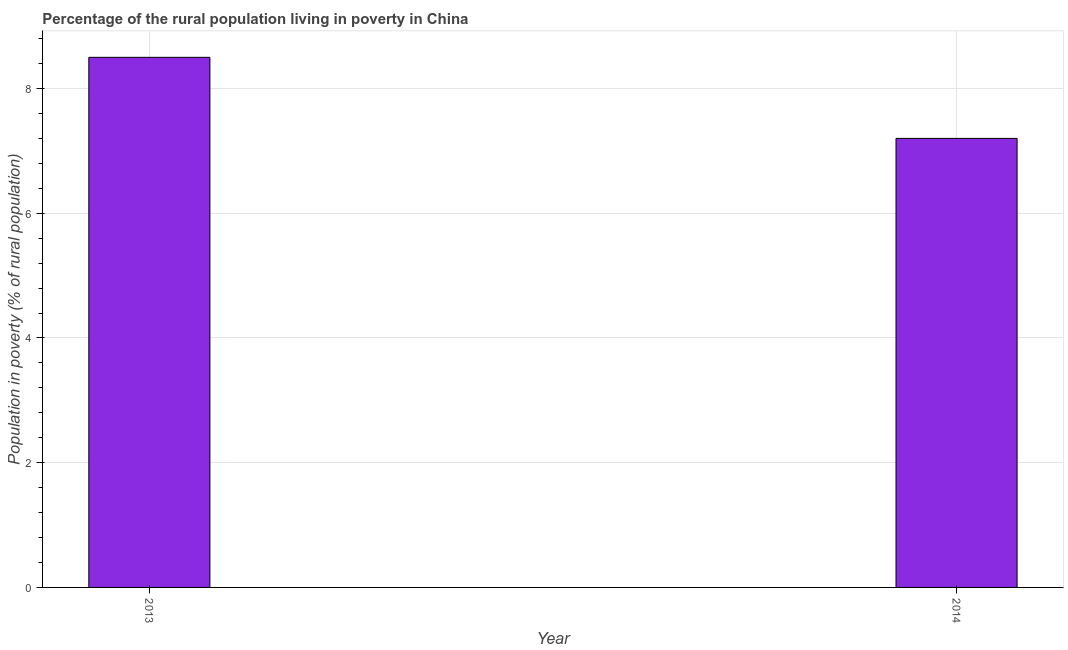What is the title of the graph?
Ensure brevity in your answer.  Percentage of the rural population living in poverty in China. What is the label or title of the Y-axis?
Keep it short and to the point. Population in poverty (% of rural population). What is the percentage of rural population living below poverty line in 2014?
Provide a short and direct response. 7.2. Across all years, what is the maximum percentage of rural population living below poverty line?
Ensure brevity in your answer.  8.5. Across all years, what is the minimum percentage of rural population living below poverty line?
Offer a terse response. 7.2. What is the difference between the percentage of rural population living below poverty line in 2013 and 2014?
Offer a terse response. 1.3. What is the average percentage of rural population living below poverty line per year?
Ensure brevity in your answer.  7.85. What is the median percentage of rural population living below poverty line?
Ensure brevity in your answer.  7.85. In how many years, is the percentage of rural population living below poverty line greater than 4.4 %?
Offer a very short reply. 2. What is the ratio of the percentage of rural population living below poverty line in 2013 to that in 2014?
Provide a succinct answer. 1.18. Is the percentage of rural population living below poverty line in 2013 less than that in 2014?
Offer a very short reply. No. In how many years, is the percentage of rural population living below poverty line greater than the average percentage of rural population living below poverty line taken over all years?
Make the answer very short. 1. How many bars are there?
Your answer should be compact. 2. What is the Population in poverty (% of rural population) in 2013?
Give a very brief answer. 8.5. What is the difference between the Population in poverty (% of rural population) in 2013 and 2014?
Provide a succinct answer. 1.3. What is the ratio of the Population in poverty (% of rural population) in 2013 to that in 2014?
Your response must be concise. 1.18. 